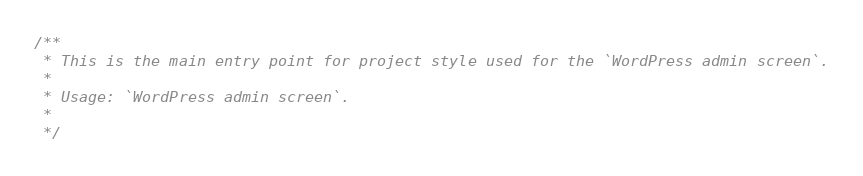<code> <loc_0><loc_0><loc_500><loc_500><_CSS_>/**
 * This is the main entry point for project style used for the `WordPress admin screen`.
 *
 * Usage: `WordPress admin screen`.
 *
 */

</code> 